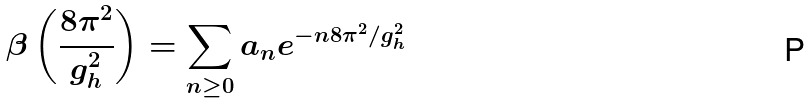Convert formula to latex. <formula><loc_0><loc_0><loc_500><loc_500>\beta \left ( \frac { 8 \pi ^ { 2 } } { g ^ { 2 } _ { h } } \right ) = \sum _ { n \geq 0 } a _ { n } e ^ { - n 8 \pi ^ { 2 } / g ^ { 2 } _ { h } }</formula> 